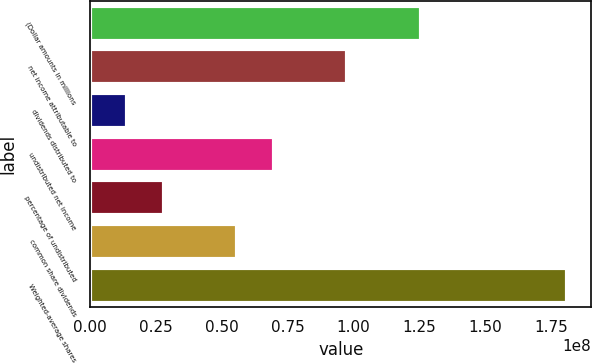Convert chart. <chart><loc_0><loc_0><loc_500><loc_500><bar_chart><fcel>(Dollar amounts in millions<fcel>net income attributable to<fcel>dividends distributed to<fcel>undistributed net income<fcel>percentage of undistributed<fcel>common share dividends<fcel>Weighted-average shares<nl><fcel>1.25533e+08<fcel>9.7637e+07<fcel>1.39482e+07<fcel>6.97407e+07<fcel>2.78963e+07<fcel>5.57926e+07<fcel>1.81326e+08<nl></chart> 